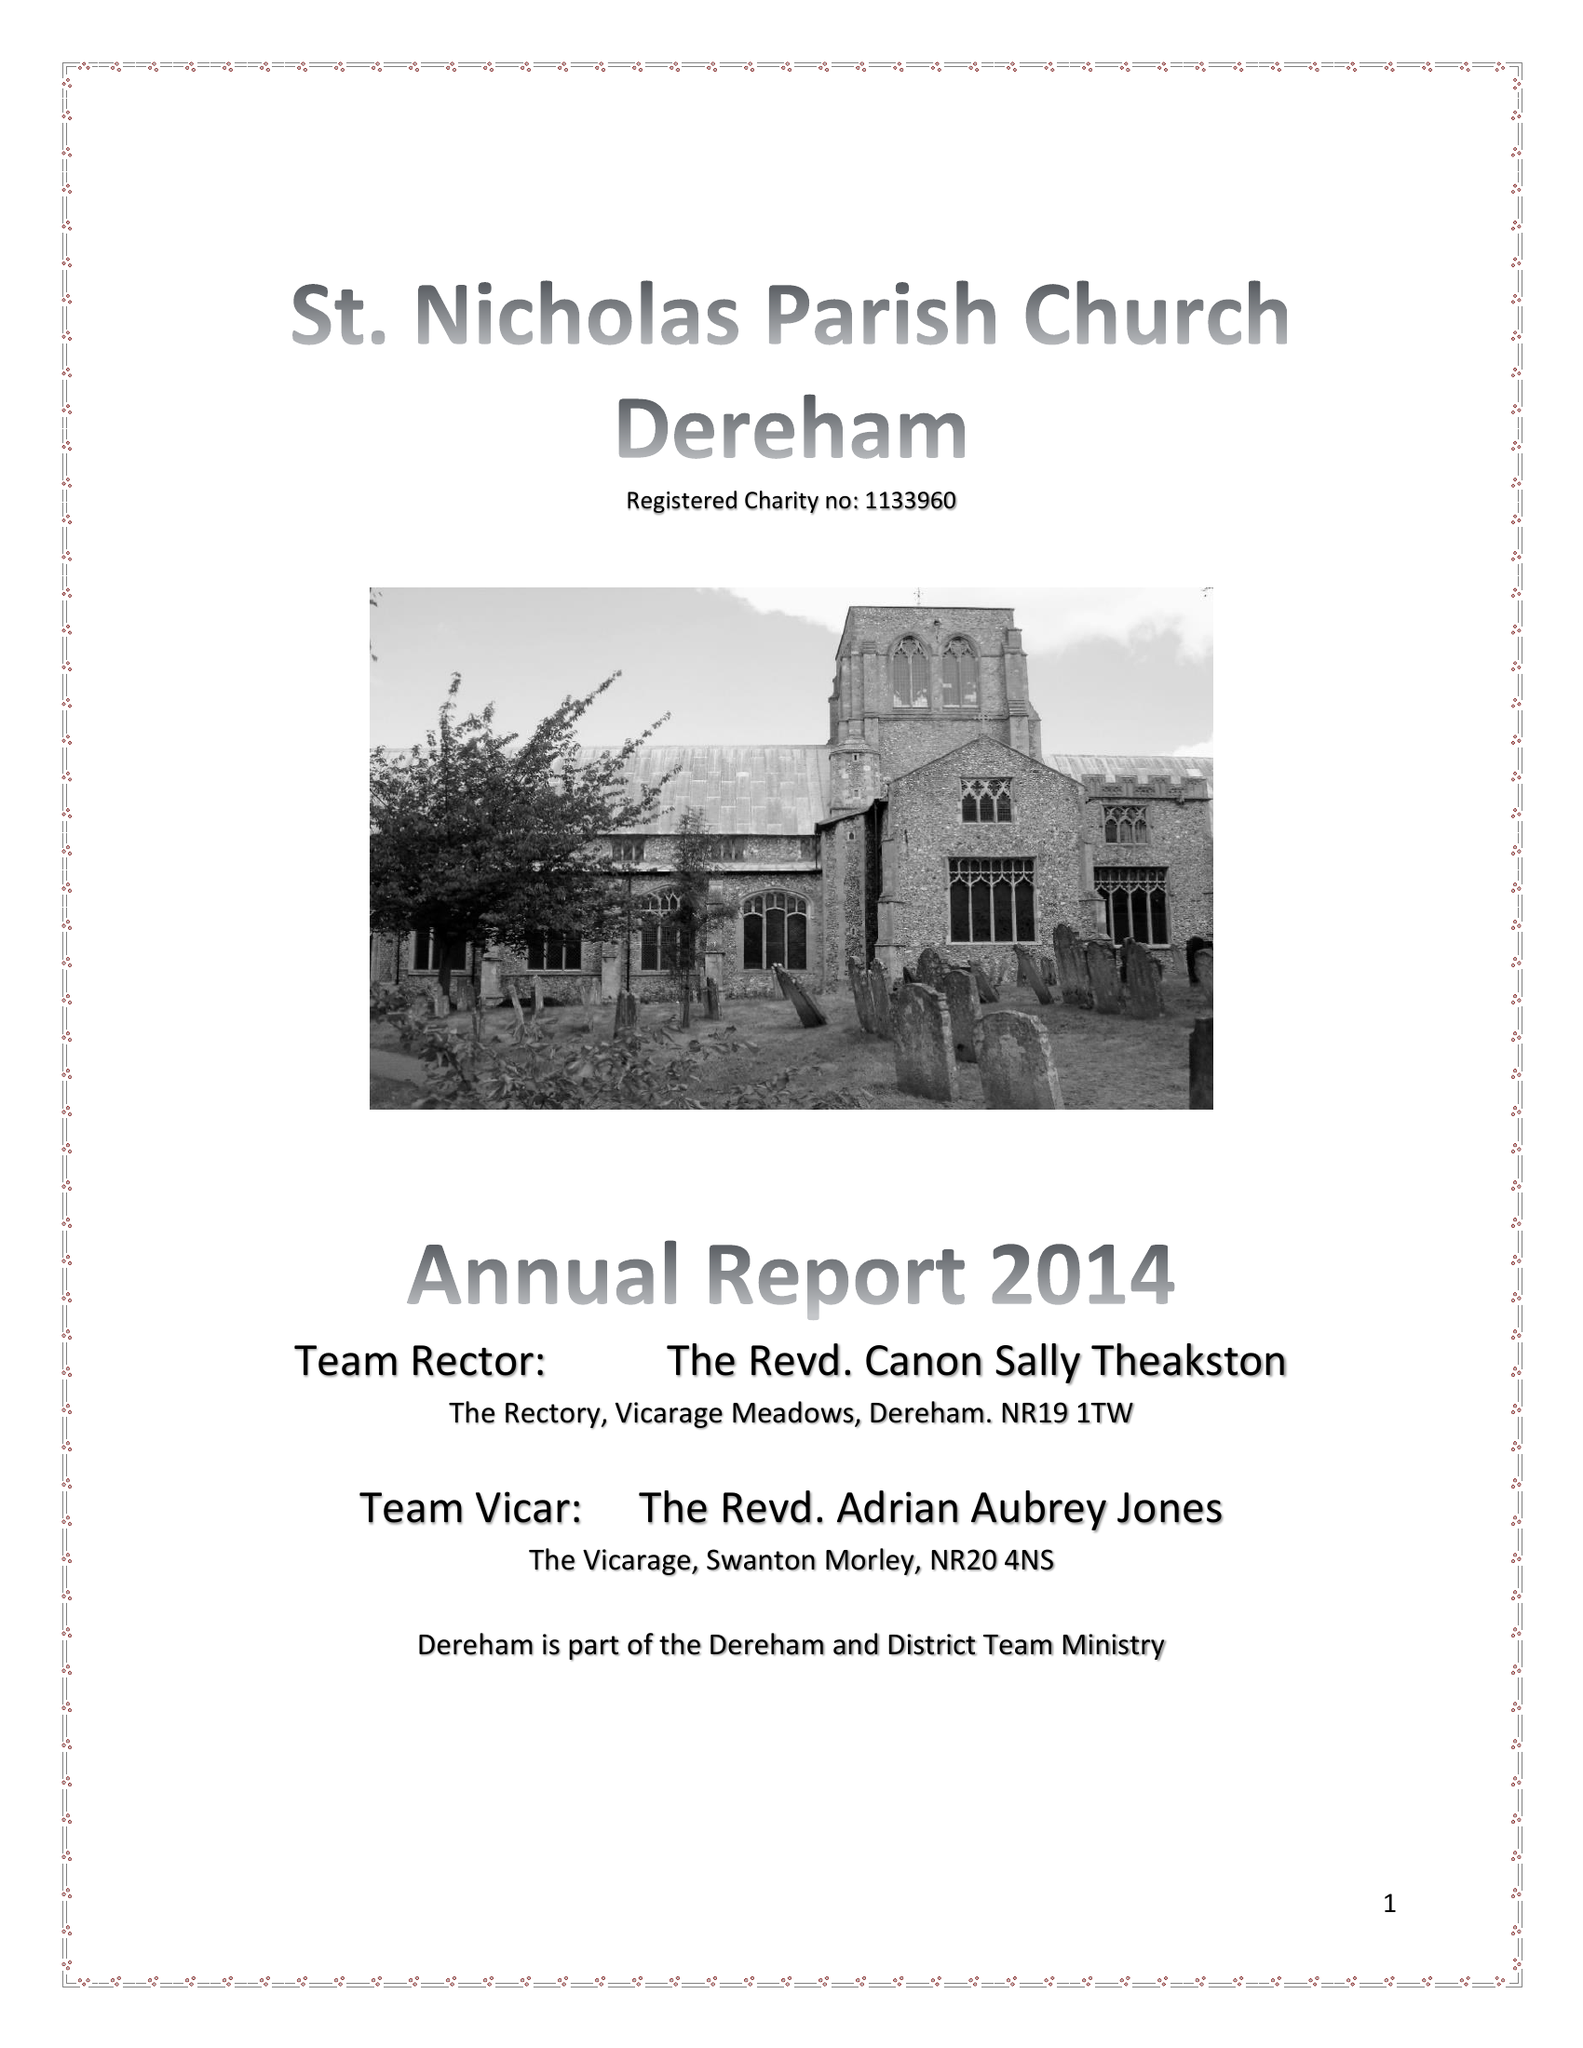What is the value for the charity_name?
Answer the question using a single word or phrase. The Parochial Church Council Of The Ecclesiastical Parish Of St Nicholas, Dereham 